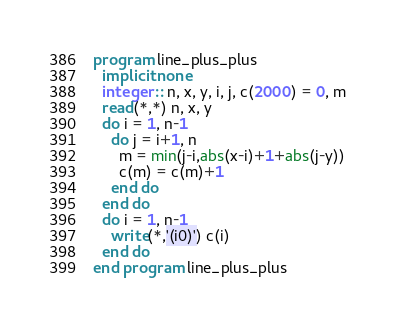<code> <loc_0><loc_0><loc_500><loc_500><_FORTRAN_>program line_plus_plus
  implicit none
  integer :: n, x, y, i, j, c(2000) = 0, m
  read(*,*) n, x, y
  do i = 1, n-1
    do j = i+1, n
      m = min(j-i,abs(x-i)+1+abs(j-y))
      c(m) = c(m)+1
    end do
  end do
  do i = 1, n-1
    write(*,'(i0)') c(i)
  end do
end program line_plus_plus</code> 